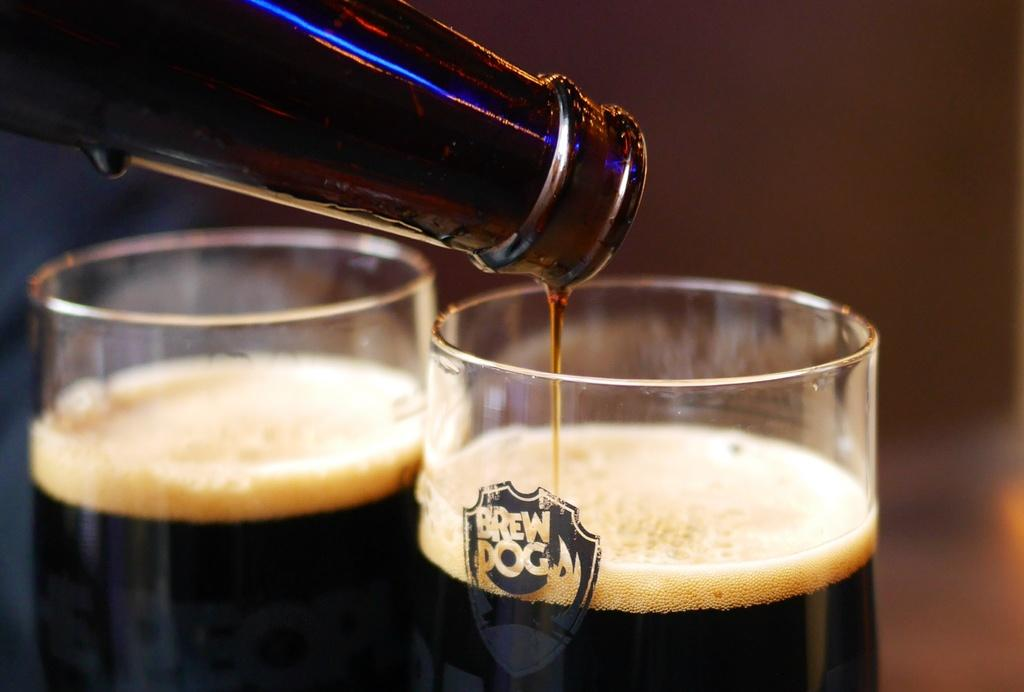<image>
Relay a brief, clear account of the picture shown. Person pouring alcohol into a cup that says Brew Dog on it. 